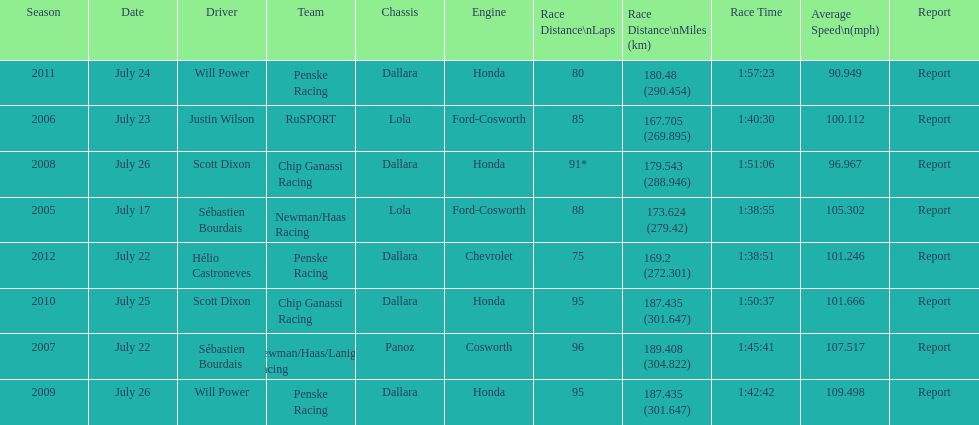Write the full table. {'header': ['Season', 'Date', 'Driver', 'Team', 'Chassis', 'Engine', 'Race Distance\\nLaps', 'Race Distance\\nMiles (km)', 'Race Time', 'Average Speed\\n(mph)', 'Report'], 'rows': [['2011', 'July 24', 'Will Power', 'Penske Racing', 'Dallara', 'Honda', '80', '180.48 (290.454)', '1:57:23', '90.949', 'Report'], ['2006', 'July 23', 'Justin Wilson', 'RuSPORT', 'Lola', 'Ford-Cosworth', '85', '167.705 (269.895)', '1:40:30', '100.112', 'Report'], ['2008', 'July 26', 'Scott Dixon', 'Chip Ganassi Racing', 'Dallara', 'Honda', '91*', '179.543 (288.946)', '1:51:06', '96.967', 'Report'], ['2005', 'July 17', 'Sébastien Bourdais', 'Newman/Haas Racing', 'Lola', 'Ford-Cosworth', '88', '173.624 (279.42)', '1:38:55', '105.302', 'Report'], ['2012', 'July 22', 'Hélio Castroneves', 'Penske Racing', 'Dallara', 'Chevrolet', '75', '169.2 (272.301)', '1:38:51', '101.246', 'Report'], ['2010', 'July 25', 'Scott Dixon', 'Chip Ganassi Racing', 'Dallara', 'Honda', '95', '187.435 (301.647)', '1:50:37', '101.666', 'Report'], ['2007', 'July 22', 'Sébastien Bourdais', 'Newman/Haas/Lanigan Racing', 'Panoz', 'Cosworth', '96', '189.408 (304.822)', '1:45:41', '107.517', 'Report'], ['2009', 'July 26', 'Will Power', 'Penske Racing', 'Dallara', 'Honda', '95', '187.435 (301.647)', '1:42:42', '109.498', 'Report']]} How many different teams are represented in the table? 4. 